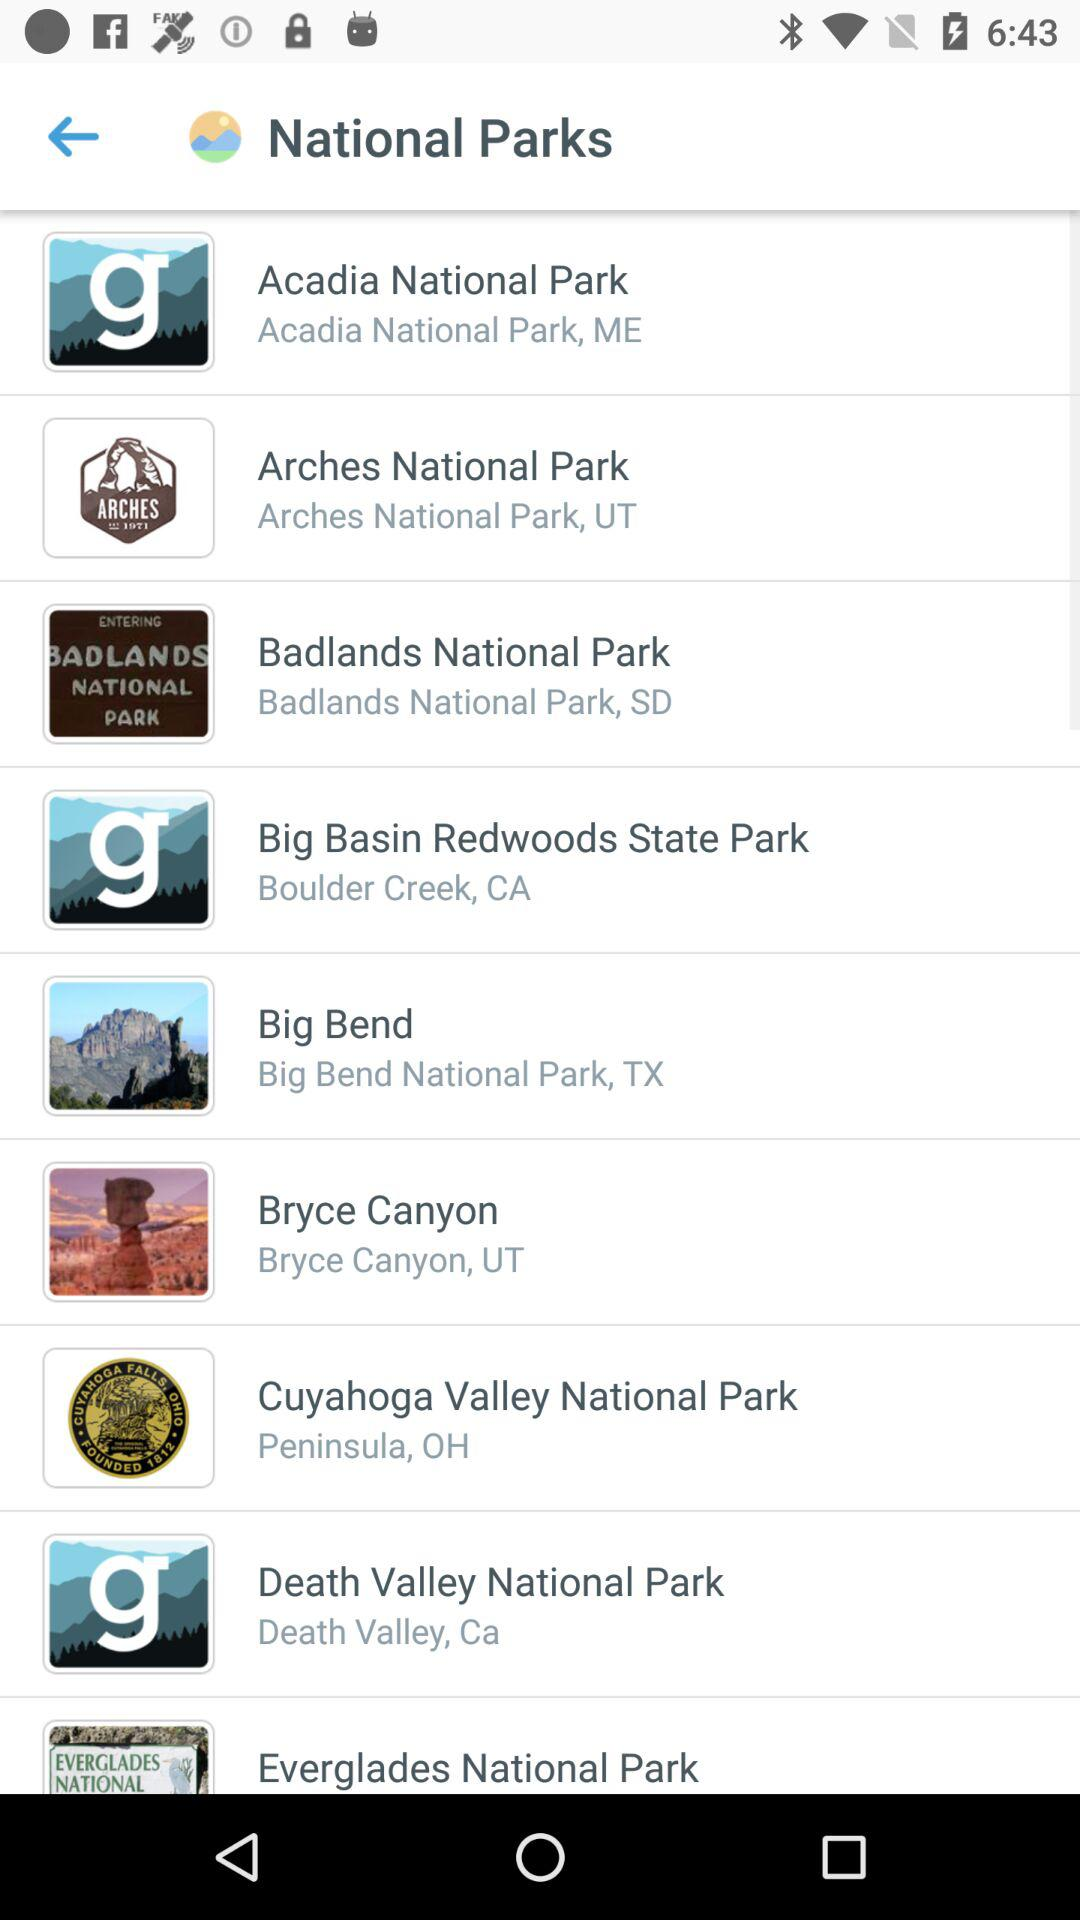What are the names of the different national parks shown on the screen? The names of the different national parks are "Acadia National Park", "Arches National Park", "Badlands National Park", "Big Basin Redwoods State Park", "Big Bend", "Bryce Canyon", "Cuyahoga Valley National Park", "Death Valley National Park" and "Everglades National Park". 